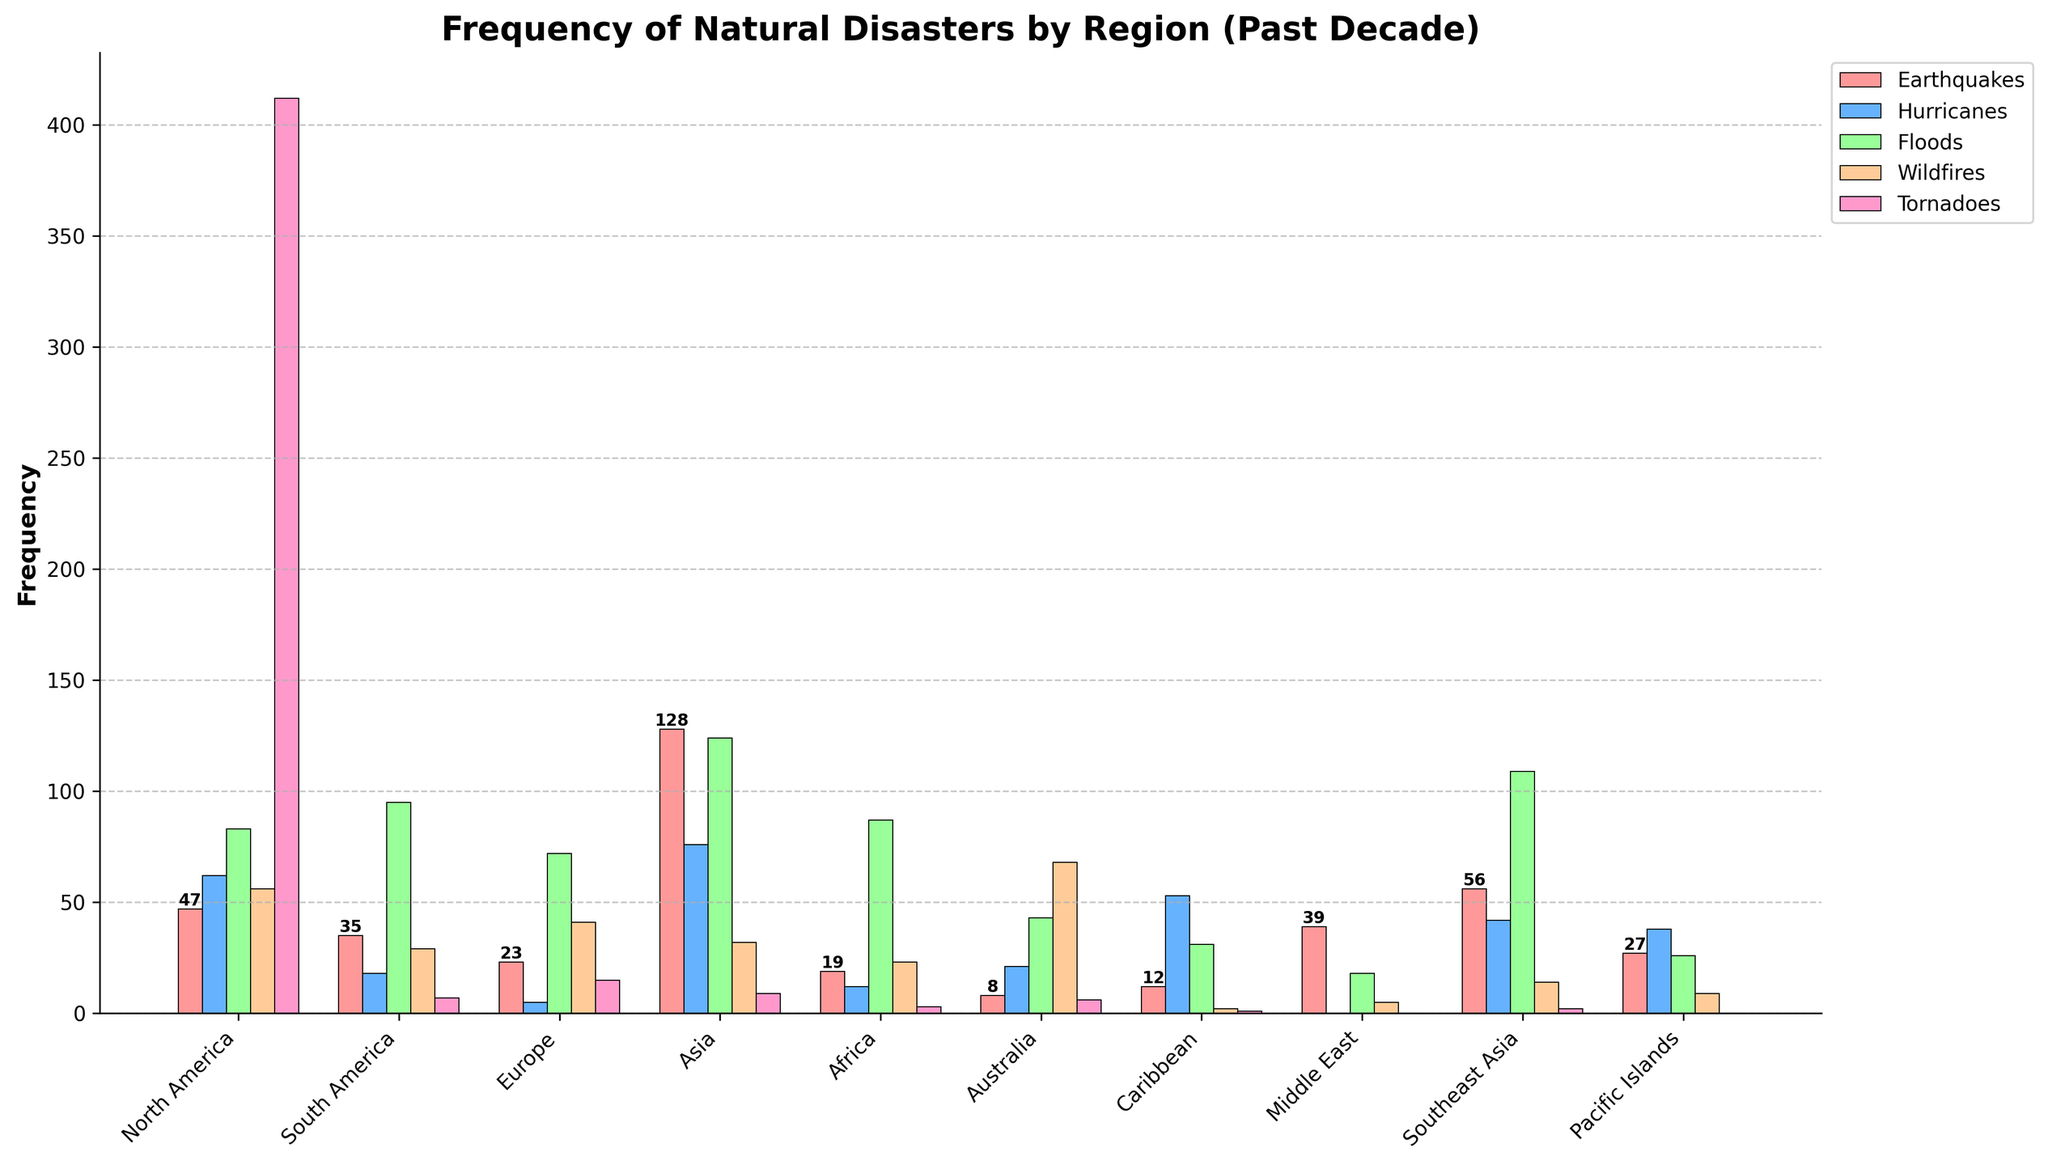What region experienced the most earthquakes? By looking at the height of the bars in the earthquake category, we can see that Asia has the highest bar.
Answer: Asia Which region had more hurricanes: North America or the Caribbean? Compare the heights of the bars representing hurricanes for these regions. The bar for North America (62) is higher than the bar for the Caribbean (53).
Answer: North America What is the total number of floods in South America and Africa? Add the frequency of floods in South America (95) and Africa (87) using simple addition: 95 + 87 = 182.
Answer: 182 Which region had the fewest tornadoes? By reviewing the height of the tornado bars across all regions, we see that the Middle East and Pacific Islands both have a bar height of zero.
Answer: Middle East, Pacific Islands What is the average frequency of wildfires across all regions? Add up all the frequencies of wildfires across the regions and divide by the number of regions: (56 + 29 + 41 + 32 + 23 + 68 + 2 + 5 + 14 + 9)/10 = 279/10 = 27.9.
Answer: 27.9 Which region experienced more wildfires: Australia or North America? Compare the wildfires bar height for Australia (68) and North America (56). Australia has the higher number.
Answer: Australia In which region do hurricanes occur more frequently than tornadoes? By comparing hurricane and tornado frequencies, all regions except North America and South America show higher or equal frequencies for hurricanes than tornadoes.
Answer: All except North America, South America What is the total frequency of natural disasters (sum of all types) in the Caribbean? Summing the frequency of all disasters in the Caribbean: 12 (earthquakes) + 53 (hurricanes) + 31 (floods) + 2 (wildfires) + 1 (tornadoes) = 99.
Answer: 99 Which disaster is most frequent in Europe? Compare the heights of the bars for each disaster in Europe. Floods (72) have the highest frequency.
Answer: Floods 